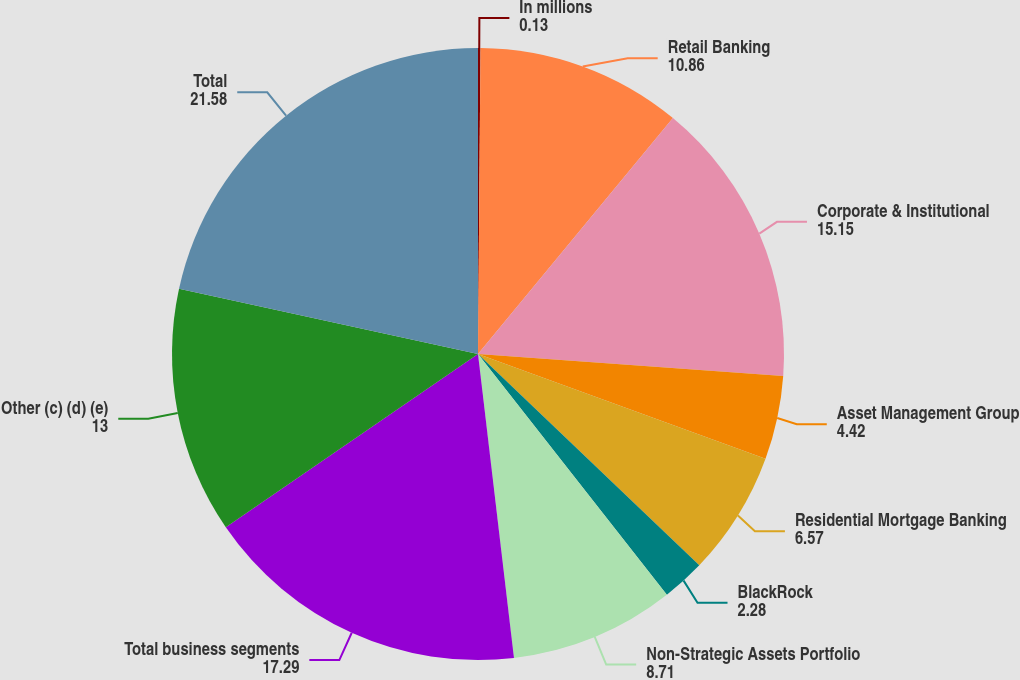<chart> <loc_0><loc_0><loc_500><loc_500><pie_chart><fcel>In millions<fcel>Retail Banking<fcel>Corporate & Institutional<fcel>Asset Management Group<fcel>Residential Mortgage Banking<fcel>BlackRock<fcel>Non-Strategic Assets Portfolio<fcel>Total business segments<fcel>Other (c) (d) (e)<fcel>Total<nl><fcel>0.13%<fcel>10.86%<fcel>15.15%<fcel>4.42%<fcel>6.57%<fcel>2.28%<fcel>8.71%<fcel>17.29%<fcel>13.0%<fcel>21.58%<nl></chart> 